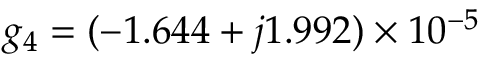Convert formula to latex. <formula><loc_0><loc_0><loc_500><loc_500>g _ { 4 } = ( - 1 . 6 4 4 + j 1 . 9 9 2 ) \times 1 0 ^ { - 5 }</formula> 